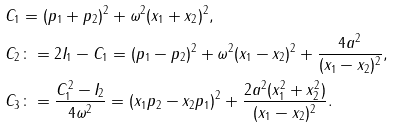Convert formula to latex. <formula><loc_0><loc_0><loc_500><loc_500>& C _ { 1 } = ( p _ { 1 } + p _ { 2 } ) ^ { 2 } + \omega ^ { 2 } ( x _ { 1 } + x _ { 2 } ) ^ { 2 } , \\ & C _ { 2 } \colon = 2 I _ { 1 } - C _ { 1 } = ( p _ { 1 } - p _ { 2 } ) ^ { 2 } + \omega ^ { 2 } ( x _ { 1 } - x _ { 2 } ) ^ { 2 } + \frac { 4 a ^ { 2 } } { ( x _ { 1 } - x _ { 2 } ) ^ { 2 } } , \\ & C _ { 3 } \colon = \frac { C _ { 1 } ^ { 2 } - I _ { 2 } } { 4 \omega ^ { 2 } } = ( x _ { 1 } p _ { 2 } - x _ { 2 } p _ { 1 } ) ^ { 2 } + \frac { 2 a ^ { 2 } ( x _ { 1 } ^ { 2 } + x _ { 2 } ^ { 2 } ) } { ( x _ { 1 } - x _ { 2 } ) ^ { 2 } } .</formula> 